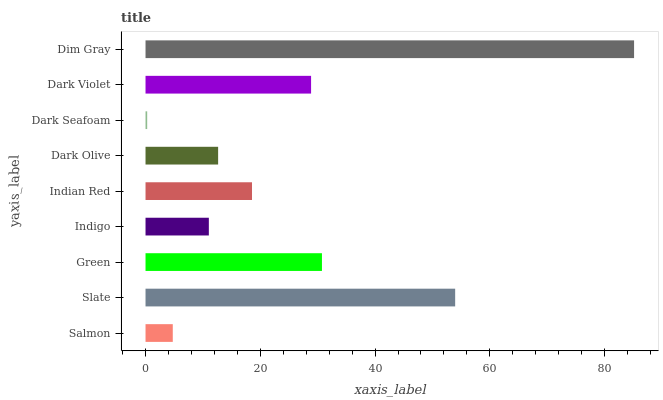Is Dark Seafoam the minimum?
Answer yes or no. Yes. Is Dim Gray the maximum?
Answer yes or no. Yes. Is Slate the minimum?
Answer yes or no. No. Is Slate the maximum?
Answer yes or no. No. Is Slate greater than Salmon?
Answer yes or no. Yes. Is Salmon less than Slate?
Answer yes or no. Yes. Is Salmon greater than Slate?
Answer yes or no. No. Is Slate less than Salmon?
Answer yes or no. No. Is Indian Red the high median?
Answer yes or no. Yes. Is Indian Red the low median?
Answer yes or no. Yes. Is Indigo the high median?
Answer yes or no. No. Is Dark Olive the low median?
Answer yes or no. No. 